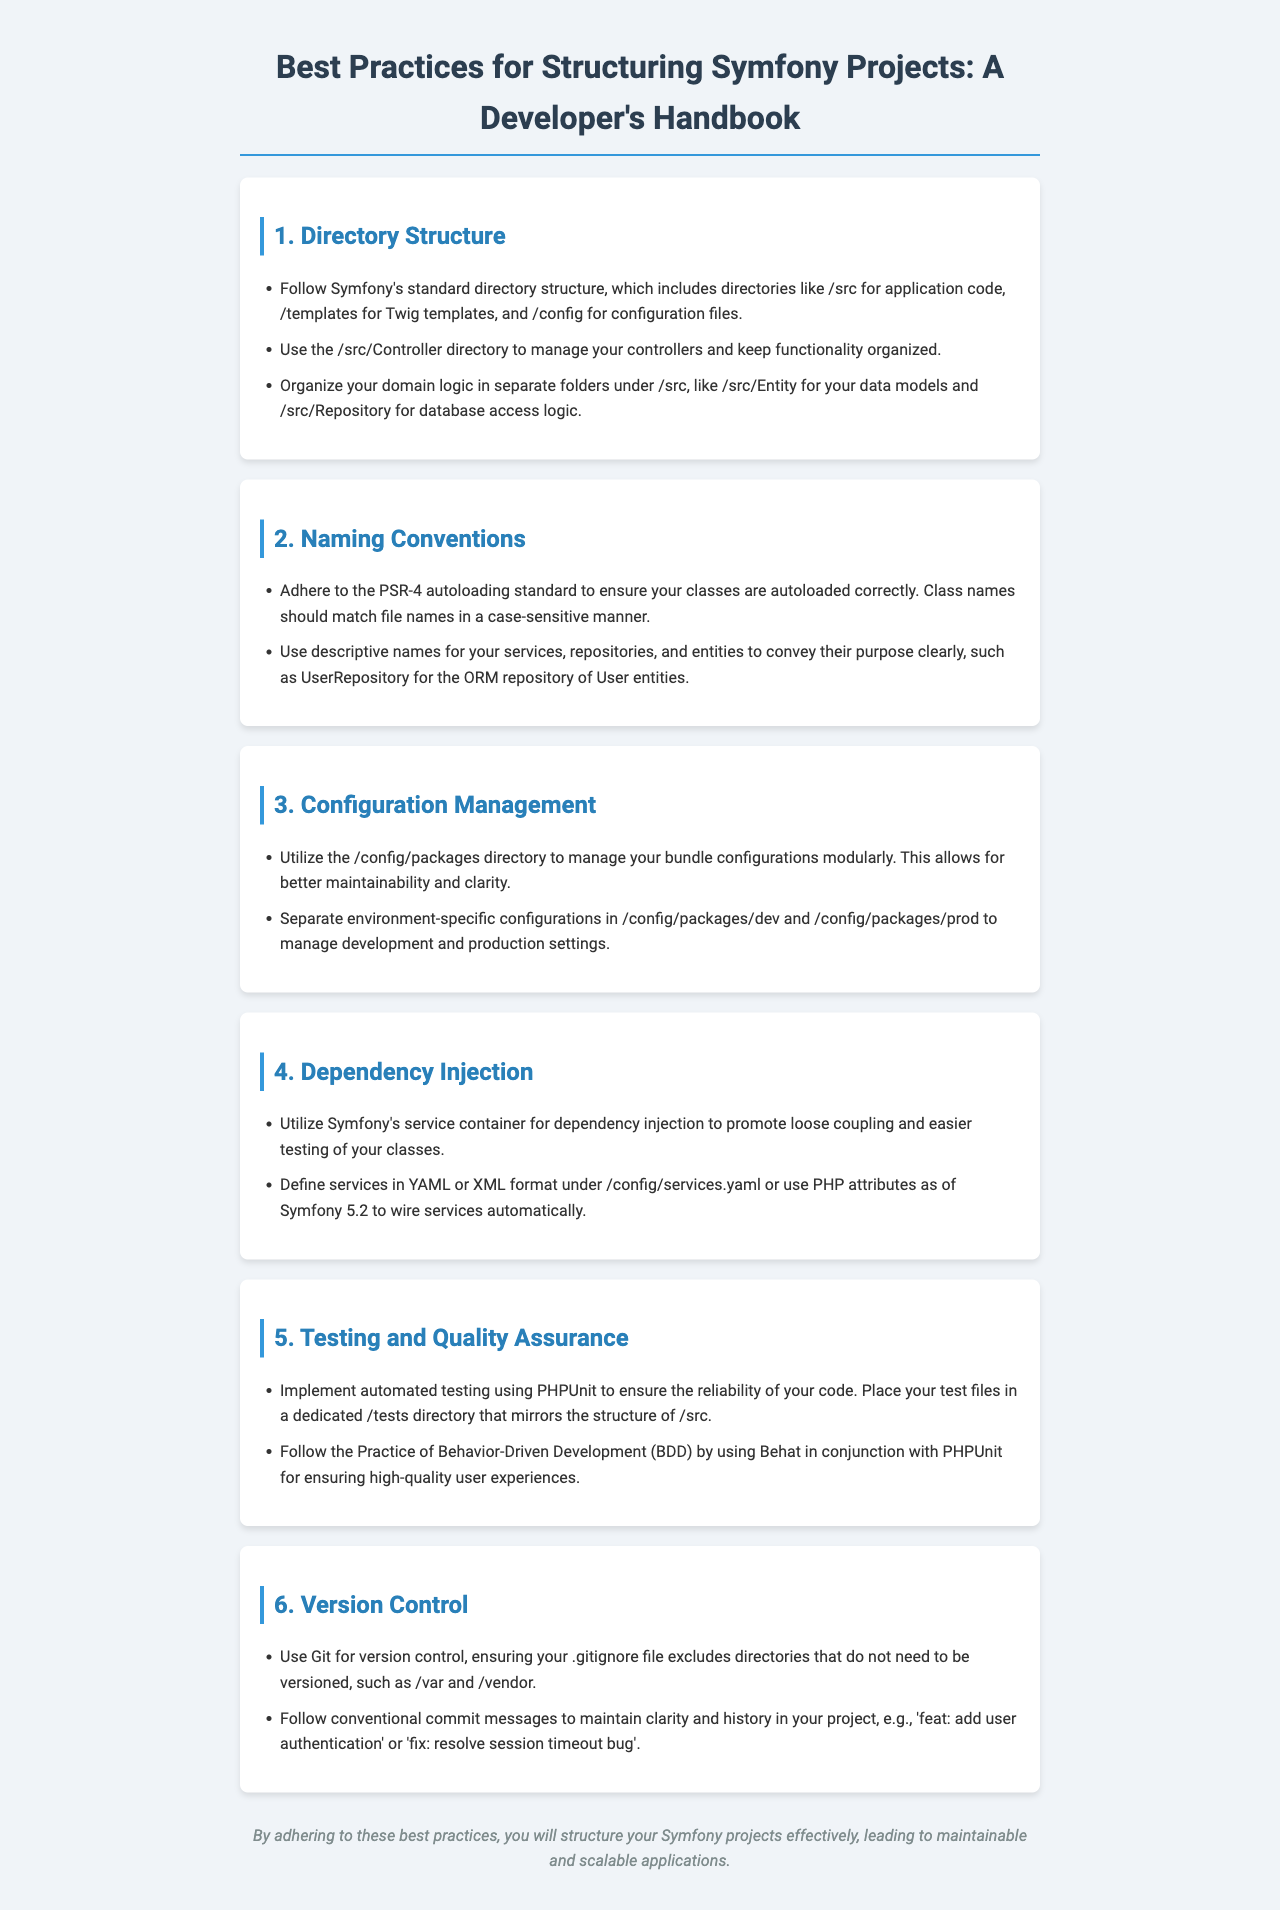What is the main topic of the document? The document outlines best practices specifically for structuring Symfony projects, which informs developers on how to effectively organize their projects.
Answer: Best Practices for Structuring Symfony Projects What directory is recommended for application code? The document specifies standard directories for a Symfony project, one of which is for application code.
Answer: /src What should be placed in the /tests directory? The discussion regarding testing mentions the placement of test files, indicating their correct location within directory structure.
Answer: Test files What is the recommended version control system? The document advises on a version control method that is commonly used in software development.
Answer: Git What is the significance of PSR-4? The document references this standard as a critical aspect of naming conventions for proper class autoloading.
Answer: Autoloading standard How should services be defined in Symfony? The recommendation for defining services within the Symfony framework is given in a specific format.
Answer: YAML or XML format What is the practice associated with maintaining clarity in commit messages? The document discusses a particular style to ensure clarity in the history of project changes through commit messages.
Answer: Conventional commit messages Which testing framework is mentioned for automated testing? The document refers to a widely-used framework that helps ensure code reliability through automated tests.
Answer: PHPUnit What does BDD stand for? The document mentions this term in the context of quality assurance practices in testing methodologies.
Answer: Behavior-Driven Development 